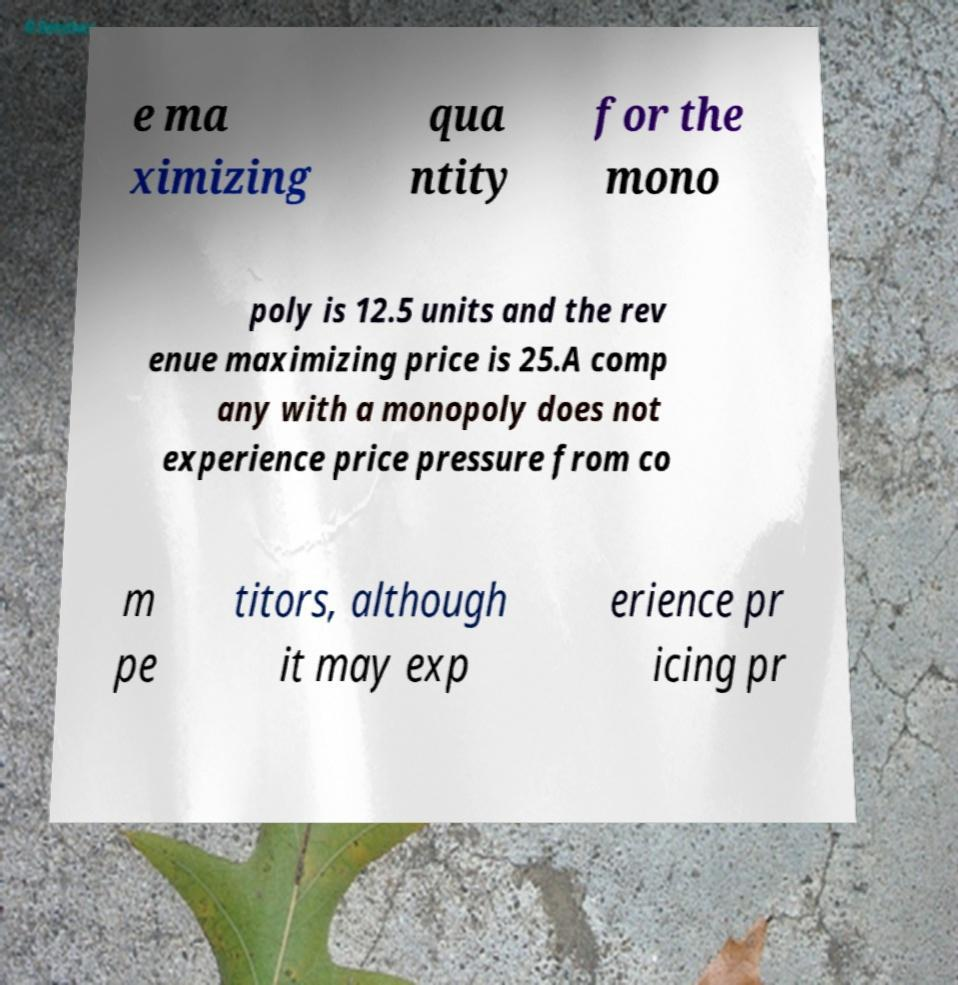Could you assist in decoding the text presented in this image and type it out clearly? e ma ximizing qua ntity for the mono poly is 12.5 units and the rev enue maximizing price is 25.A comp any with a monopoly does not experience price pressure from co m pe titors, although it may exp erience pr icing pr 